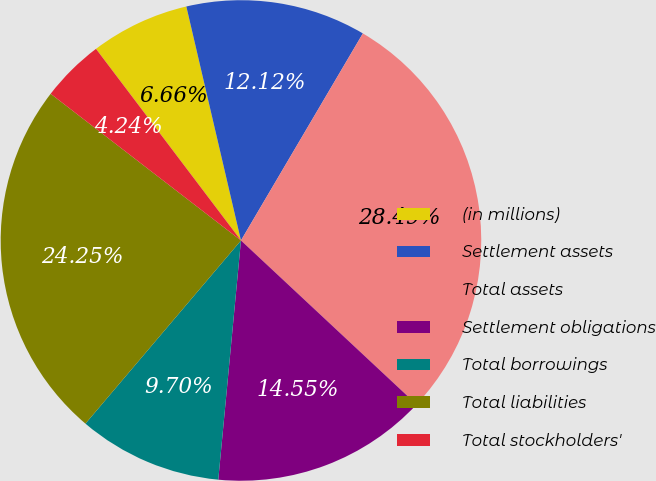<chart> <loc_0><loc_0><loc_500><loc_500><pie_chart><fcel>(in millions)<fcel>Settlement assets<fcel>Total assets<fcel>Settlement obligations<fcel>Total borrowings<fcel>Total liabilities<fcel>Total stockholders'<nl><fcel>6.66%<fcel>12.12%<fcel>28.49%<fcel>14.55%<fcel>9.7%<fcel>24.25%<fcel>4.24%<nl></chart> 